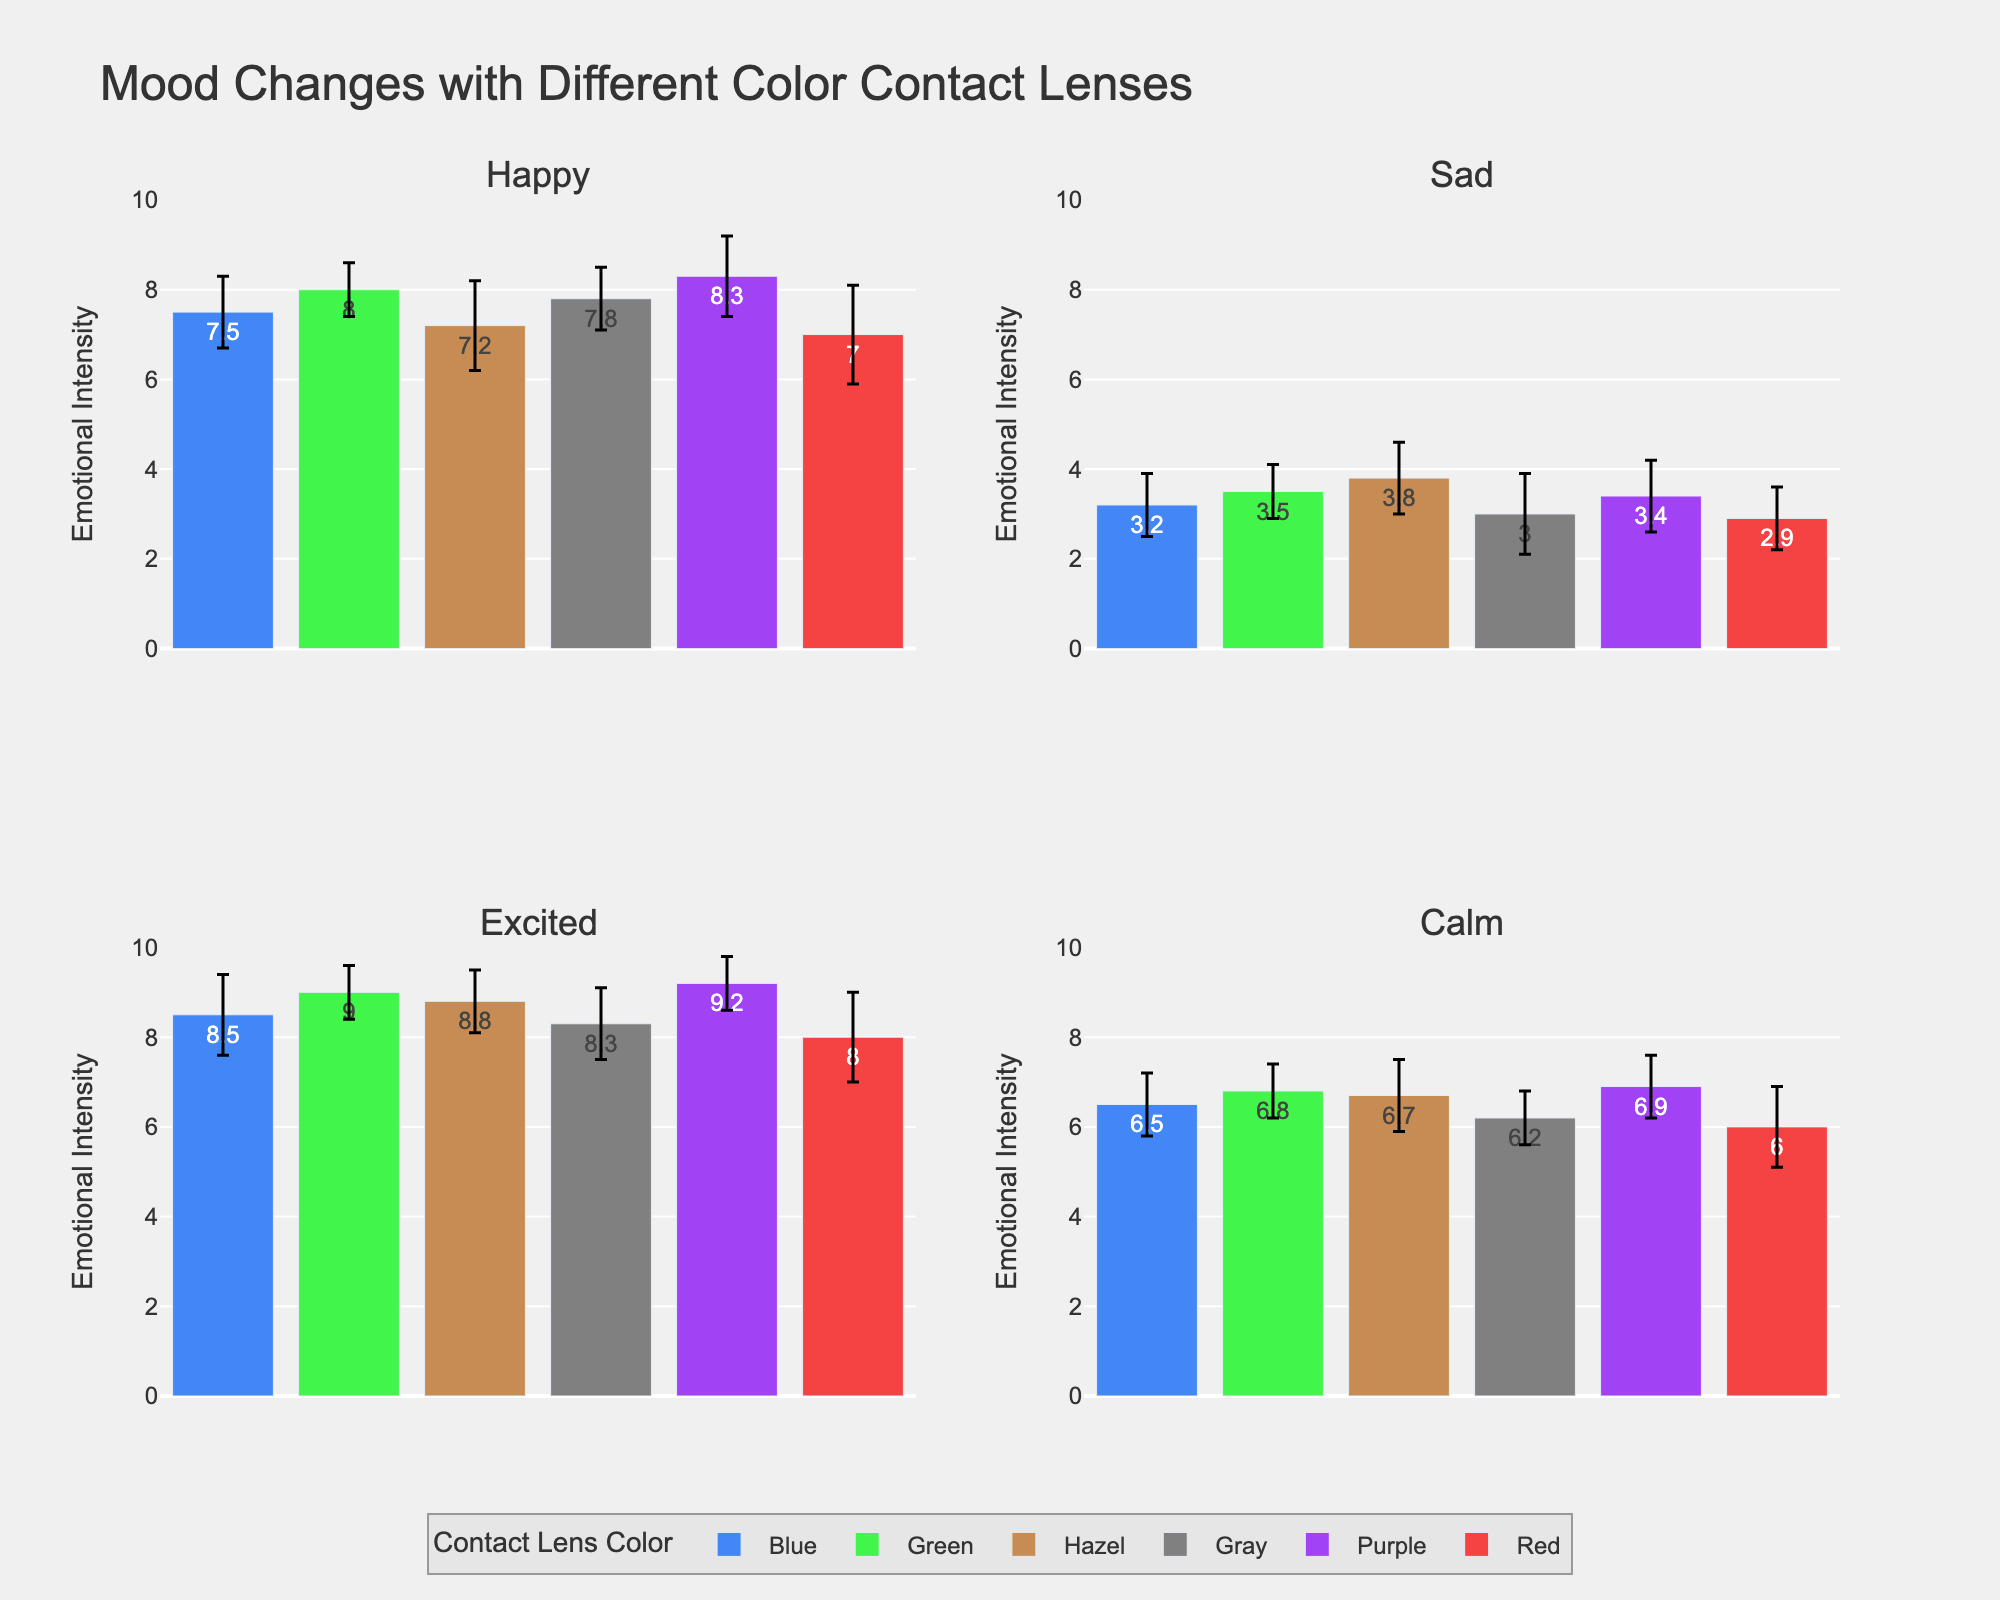What is the title of the plot? The title of the plot is found at the top center and summarizes what the figure is about. It reads "Mood Changes with Different Color Contact Lenses".
Answer: Mood Changes with Different Color Contact Lenses How many colors of contact lenses are included in the study? There are different bars representing various colors of contact lenses. Counting all unique colors across the subplots, there are six different colors.
Answer: 6 Which color contact lens has the highest mean emotional intensity in the "Excited" mood subplot? Locate the "Excited" mood subplot and compare the heights of the bars. The Purple color bar is the tallest, indicating the highest mean emotional intensity.
Answer: Purple What is the range of the y-axis in the plots? Each subplot has a y-axis that measures emotional intensity. The range is from 0 to 10, as indicated by the axis ticks.
Answer: 0 to 10 Which mood shows the lowest mean emotional intensity for the Red color contact lenses? Look for the bar representing the Red color in each subplot, and compare their heights. The "Sad" mood subplot has the lowest bar for Red.
Answer: Sad What is the difference in mean emotional intensity between Purple and Gray lenses for the "Calm" mood? Find the "Calm" subplot and note the heights of the bars for Purple and Gray. Purple has a mean of 6.9 and Gray has a mean of 6.2. Subtract these values (6.9 - 6.2).
Answer: 0.7 Which color contact lenses have an error bar (standard deviation) of 0.6 in the "Happy" mood? Within the "Happy" subplot, look for bars where the error bars show a value of 0.6. Both Green and Gray color lenses exhibit this error value.
Answer: Green and Gray What is the combined mean emotional intensity for Blue in "Happy" and "Sad" moods? Look at the "Happy" subplot and "Sad" subplot, find the Blue bars with means of 7.5 and 3.2. Add these means (7.5 + 3.2).
Answer: 10.7 Which mood has the smallest error bar for Purple color lenses? Examine the error bars for Purple lenses in each subplot. The "Excited" subplot has the smallest error bar visible.
Answer: Excited How does the mean emotional intensity for Hazel lenses in "Sad" compare to "Happy"? Compare the heights of the Hazel bars in both the "Sad" and "Happy" subplots. The "Sad" mood has a mean of 3.8, and the "Happy" mood has a mean of 7.2. The intensity is lower in "Sad".
Answer: Lower 